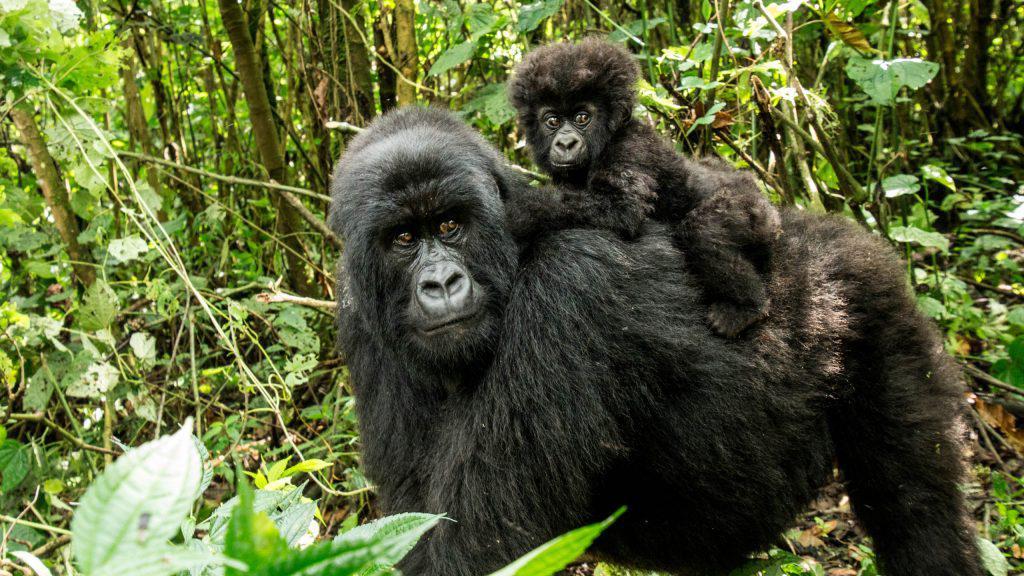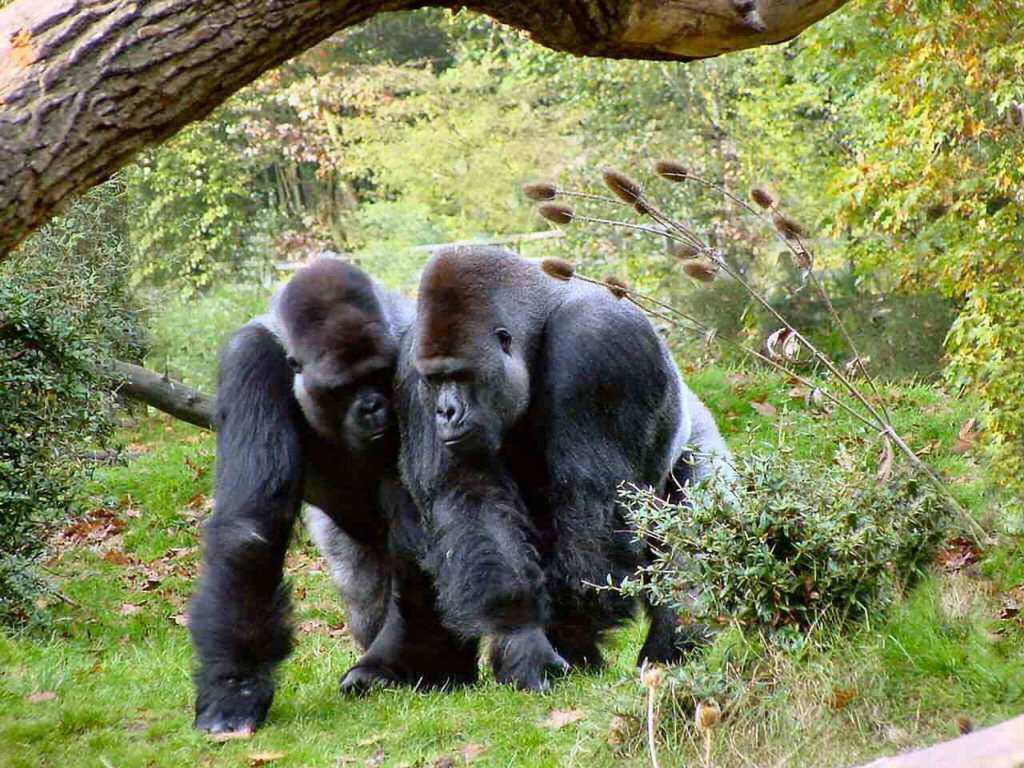The first image is the image on the left, the second image is the image on the right. Assess this claim about the two images: "The small gorilla is on top of the larger one in the image on the left.". Correct or not? Answer yes or no. Yes. The first image is the image on the left, the second image is the image on the right. Considering the images on both sides, is "All of the images have two generations of apes." valid? Answer yes or no. No. 